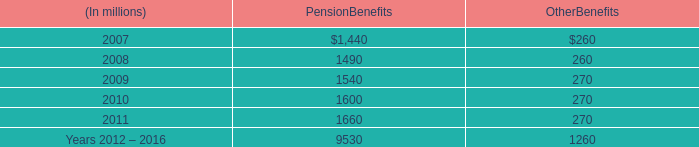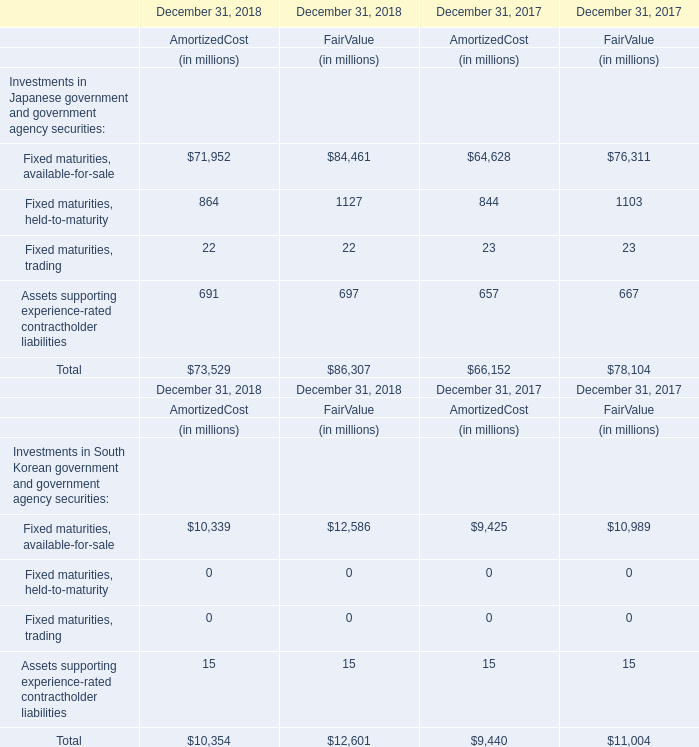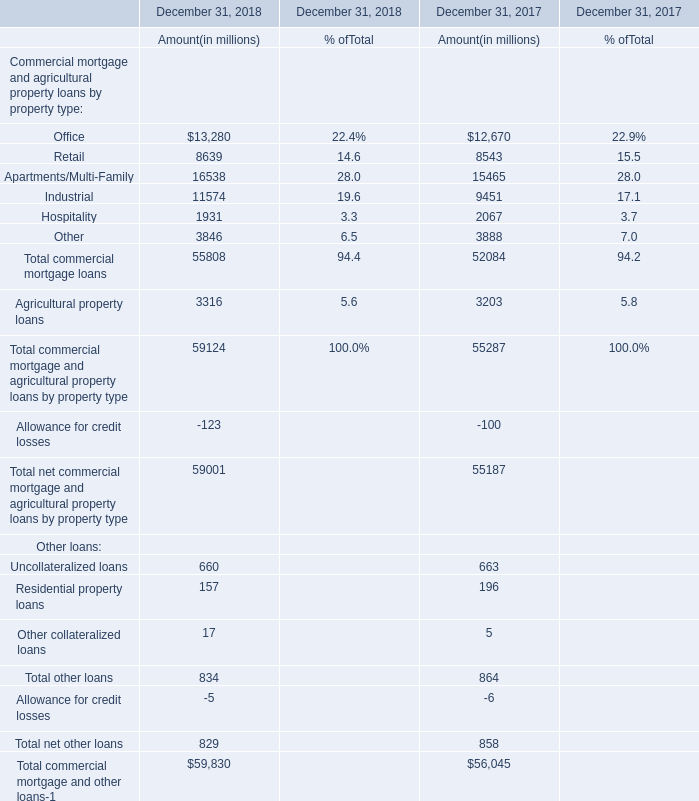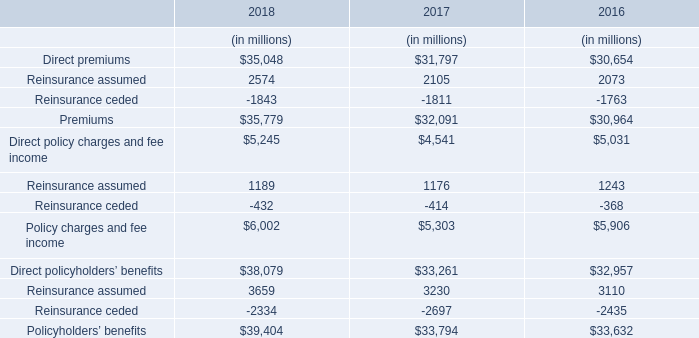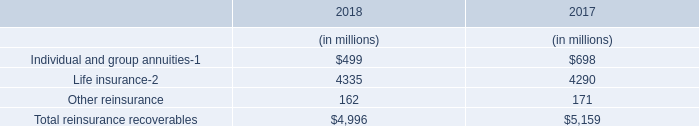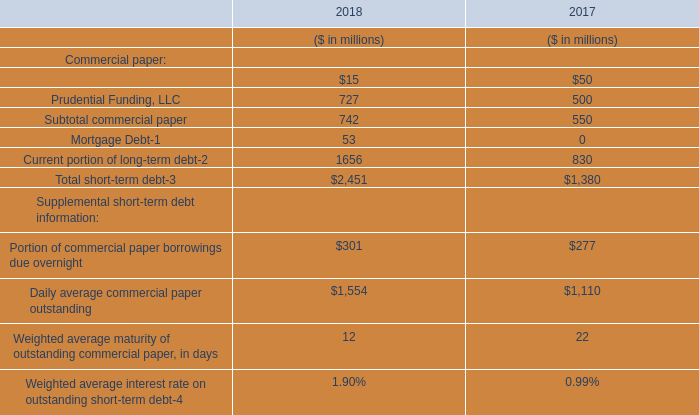What was the sum of commercial mortgage loans without those commercial mortgage loans for amount (in millions)smaller than 10000 ( in 2018 )? (in million) 
Computations: ((13280 + 16538) + 11574)
Answer: 41392.0. 